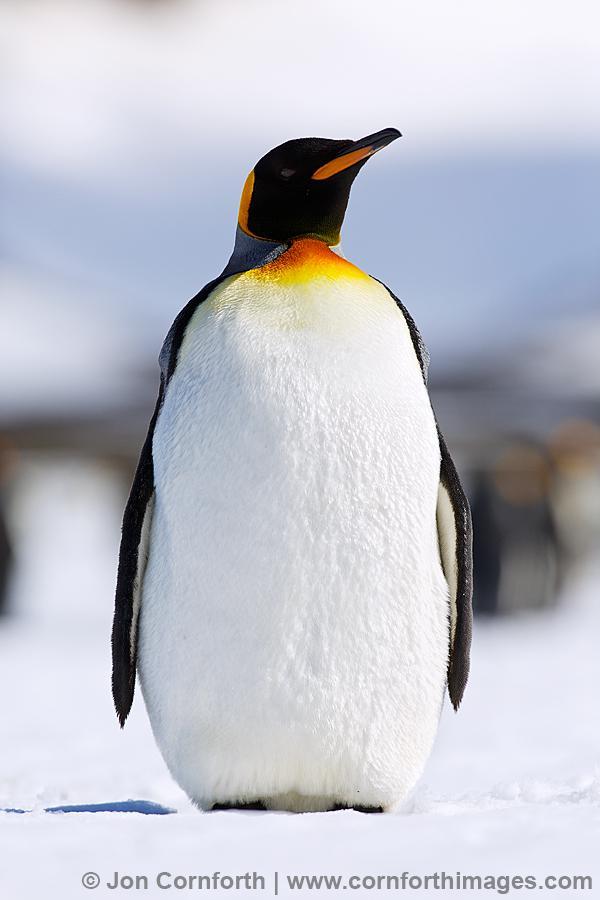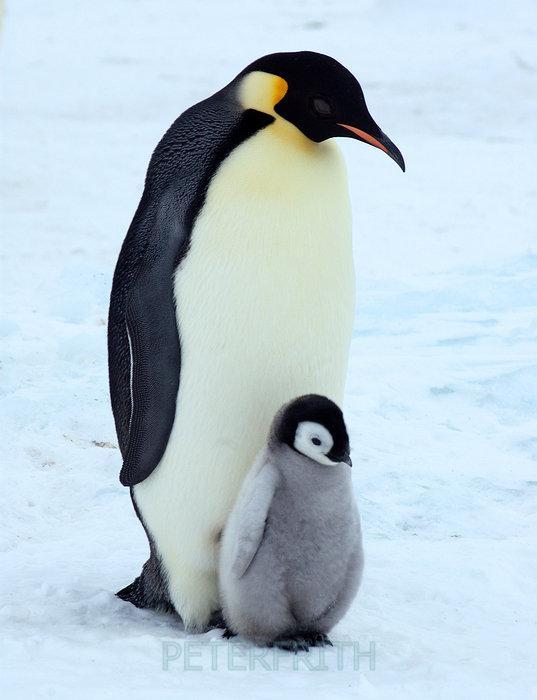The first image is the image on the left, the second image is the image on the right. Considering the images on both sides, is "There is exactly one penguin in the image on the right." valid? Answer yes or no. No. 